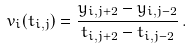Convert formula to latex. <formula><loc_0><loc_0><loc_500><loc_500>v _ { i } ( t _ { i , j } ) = \frac { y _ { i , j + 2 } - y _ { i , j - 2 } } { t _ { i , j + 2 } - t _ { i , j - 2 } } \, .</formula> 